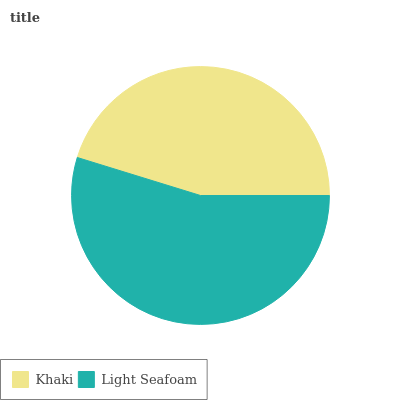Is Khaki the minimum?
Answer yes or no. Yes. Is Light Seafoam the maximum?
Answer yes or no. Yes. Is Light Seafoam the minimum?
Answer yes or no. No. Is Light Seafoam greater than Khaki?
Answer yes or no. Yes. Is Khaki less than Light Seafoam?
Answer yes or no. Yes. Is Khaki greater than Light Seafoam?
Answer yes or no. No. Is Light Seafoam less than Khaki?
Answer yes or no. No. Is Light Seafoam the high median?
Answer yes or no. Yes. Is Khaki the low median?
Answer yes or no. Yes. Is Khaki the high median?
Answer yes or no. No. Is Light Seafoam the low median?
Answer yes or no. No. 